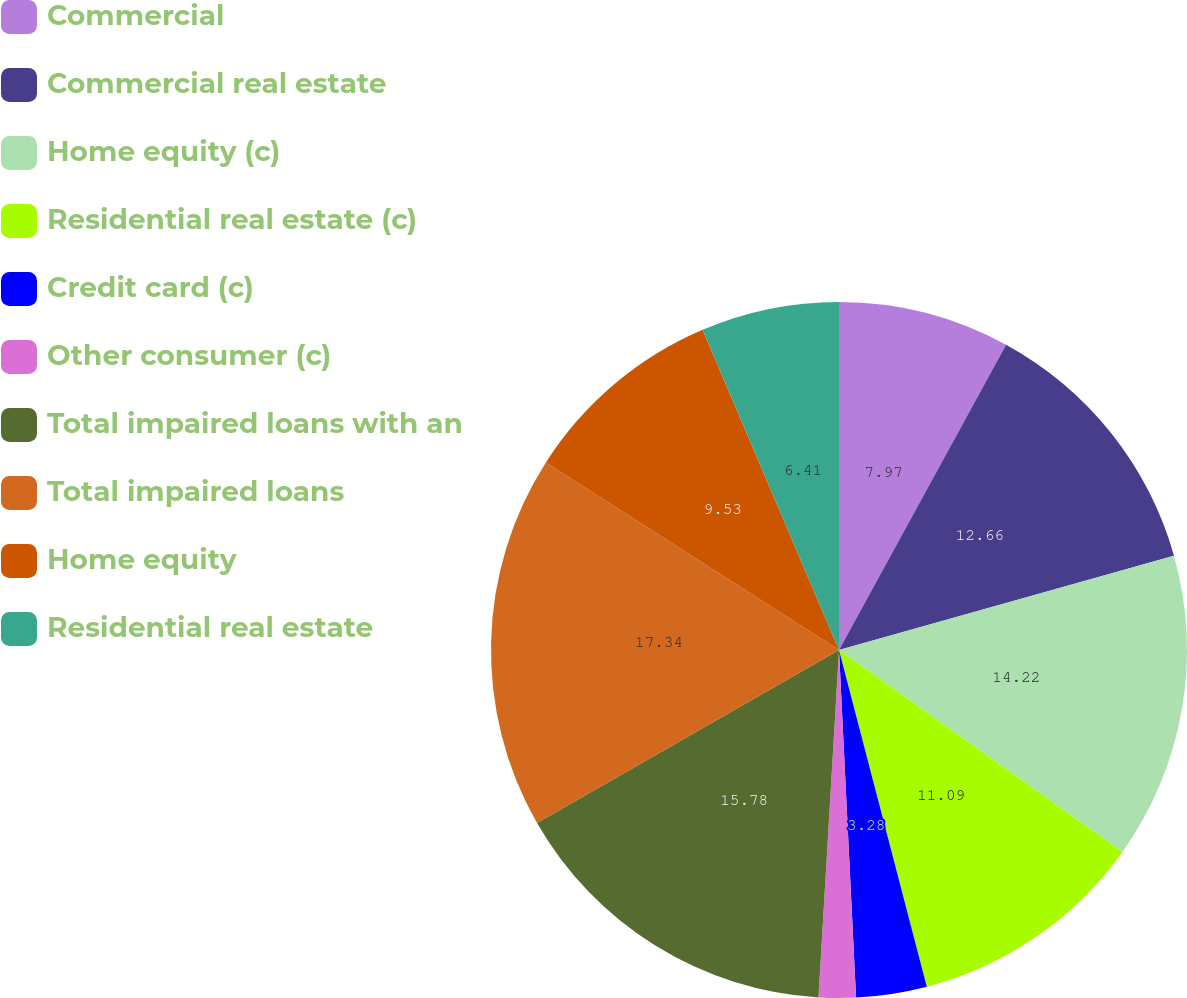Convert chart. <chart><loc_0><loc_0><loc_500><loc_500><pie_chart><fcel>Commercial<fcel>Commercial real estate<fcel>Home equity (c)<fcel>Residential real estate (c)<fcel>Credit card (c)<fcel>Other consumer (c)<fcel>Total impaired loans with an<fcel>Total impaired loans<fcel>Home equity<fcel>Residential real estate<nl><fcel>7.97%<fcel>12.66%<fcel>14.22%<fcel>11.09%<fcel>3.28%<fcel>1.72%<fcel>15.78%<fcel>17.34%<fcel>9.53%<fcel>6.41%<nl></chart> 